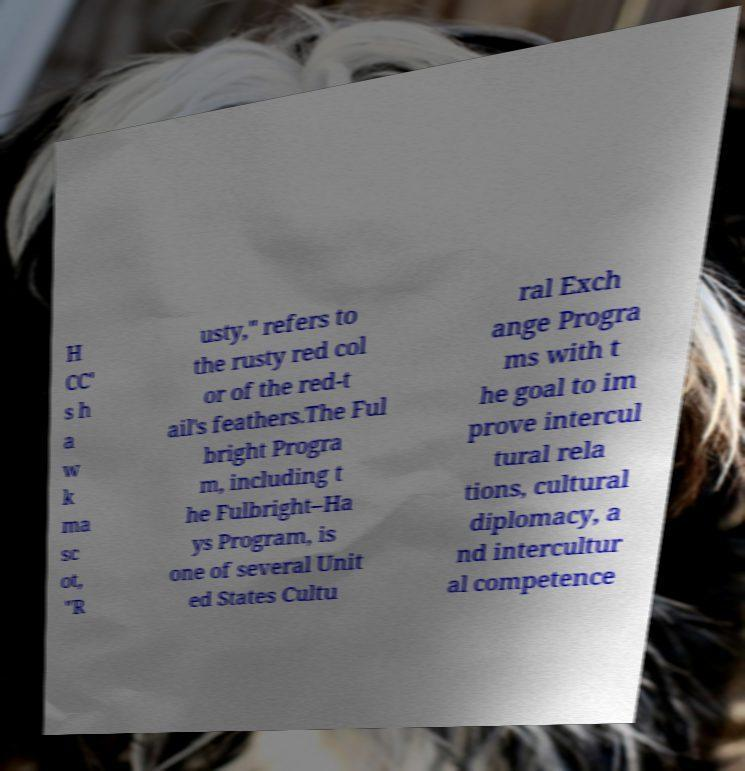Please read and relay the text visible in this image. What does it say? H CC' s h a w k ma sc ot, "R usty," refers to the rusty red col or of the red-t ail's feathers.The Ful bright Progra m, including t he Fulbright–Ha ys Program, is one of several Unit ed States Cultu ral Exch ange Progra ms with t he goal to im prove intercul tural rela tions, cultural diplomacy, a nd intercultur al competence 